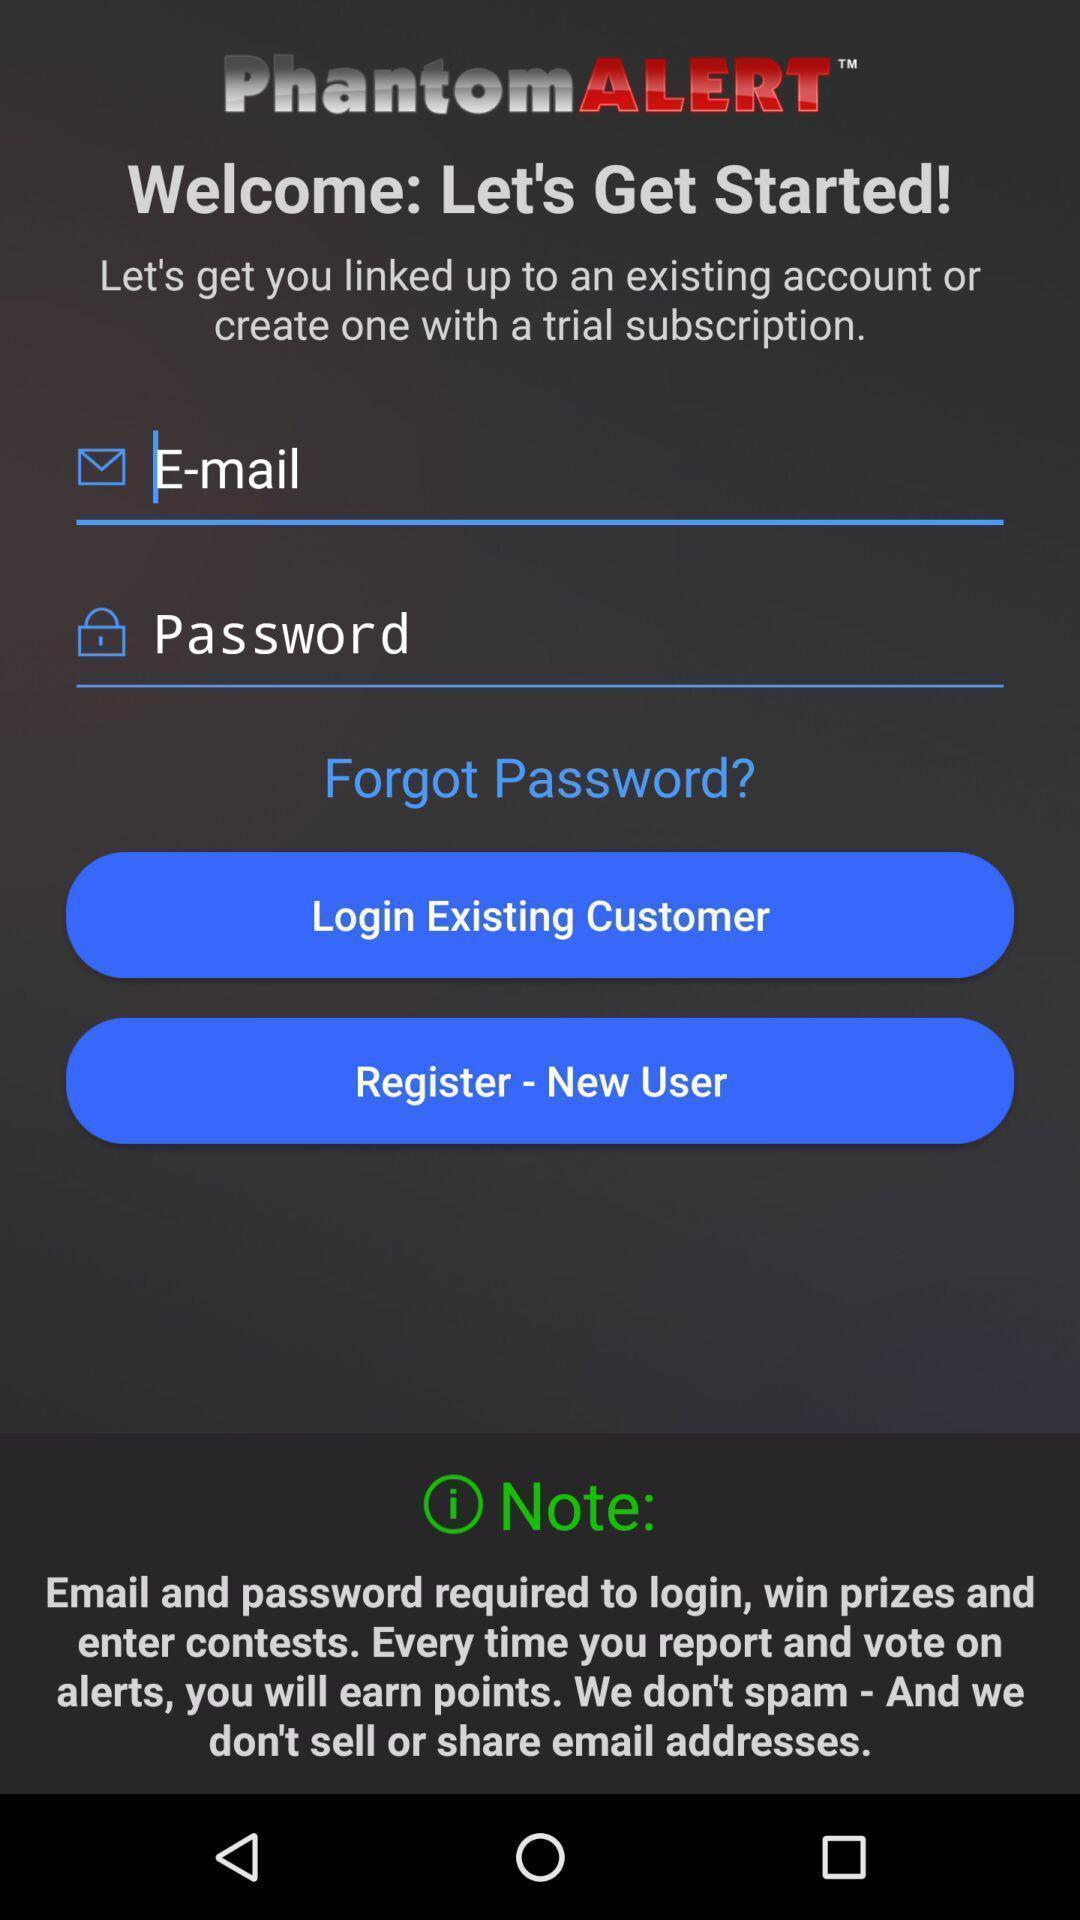Explain what's happening in this screen capture. Welcome page shows to enter a details to create account. 